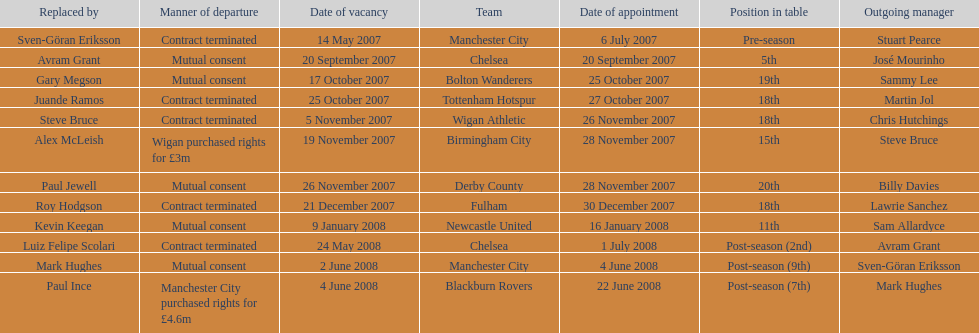Which outgoing manager was appointed the last? Mark Hughes. 